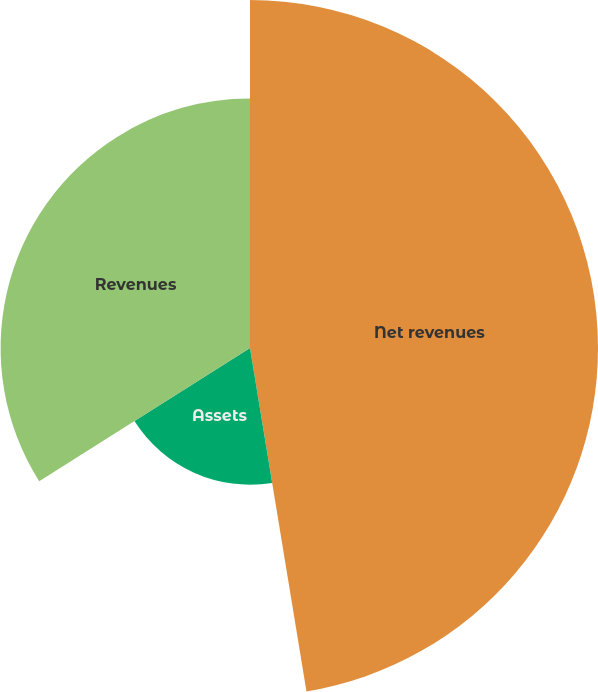<chart> <loc_0><loc_0><loc_500><loc_500><pie_chart><fcel>Net revenues<fcel>Assets<fcel>Revenues<nl><fcel>47.4%<fcel>18.62%<fcel>33.97%<nl></chart> 